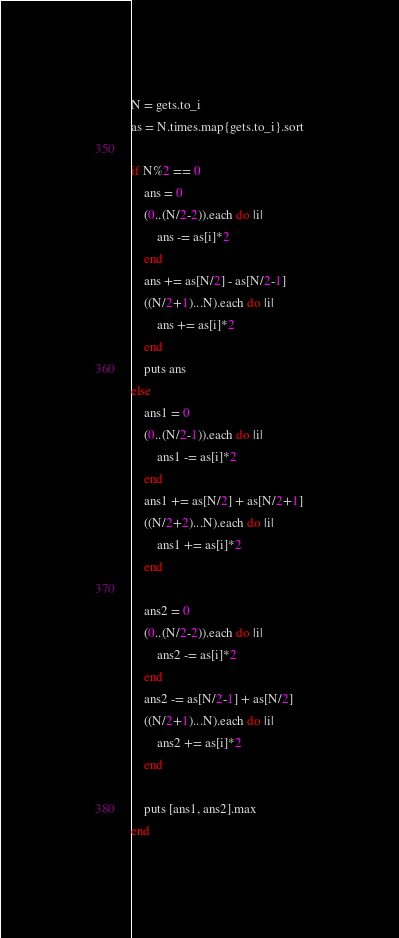<code> <loc_0><loc_0><loc_500><loc_500><_Ruby_>N = gets.to_i
as = N.times.map{gets.to_i}.sort

if N%2 == 0
    ans = 0
    (0..(N/2-2)).each do |i|
        ans -= as[i]*2
    end
    ans += as[N/2] - as[N/2-1]
    ((N/2+1)...N).each do |i|
        ans += as[i]*2
    end
    puts ans
else
    ans1 = 0
    (0..(N/2-1)).each do |i|
        ans1 -= as[i]*2
    end
    ans1 += as[N/2] + as[N/2+1]
    ((N/2+2)...N).each do |i|
        ans1 += as[i]*2
    end

    ans2 = 0
    (0..(N/2-2)).each do |i|
        ans2 -= as[i]*2
    end
    ans2 -= as[N/2-1] + as[N/2]
    ((N/2+1)...N).each do |i|
        ans2 += as[i]*2
    end

    puts [ans1, ans2].max
end</code> 